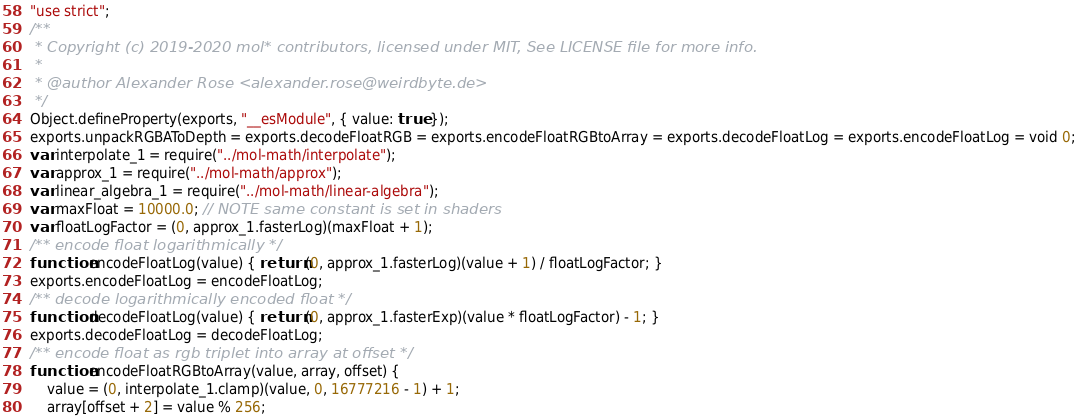<code> <loc_0><loc_0><loc_500><loc_500><_JavaScript_>"use strict";
/**
 * Copyright (c) 2019-2020 mol* contributors, licensed under MIT, See LICENSE file for more info.
 *
 * @author Alexander Rose <alexander.rose@weirdbyte.de>
 */
Object.defineProperty(exports, "__esModule", { value: true });
exports.unpackRGBAToDepth = exports.decodeFloatRGB = exports.encodeFloatRGBtoArray = exports.decodeFloatLog = exports.encodeFloatLog = void 0;
var interpolate_1 = require("../mol-math/interpolate");
var approx_1 = require("../mol-math/approx");
var linear_algebra_1 = require("../mol-math/linear-algebra");
var maxFloat = 10000.0; // NOTE same constant is set in shaders
var floatLogFactor = (0, approx_1.fasterLog)(maxFloat + 1);
/** encode float logarithmically */
function encodeFloatLog(value) { return (0, approx_1.fasterLog)(value + 1) / floatLogFactor; }
exports.encodeFloatLog = encodeFloatLog;
/** decode logarithmically encoded float */
function decodeFloatLog(value) { return (0, approx_1.fasterExp)(value * floatLogFactor) - 1; }
exports.decodeFloatLog = decodeFloatLog;
/** encode float as rgb triplet into array at offset */
function encodeFloatRGBtoArray(value, array, offset) {
    value = (0, interpolate_1.clamp)(value, 0, 16777216 - 1) + 1;
    array[offset + 2] = value % 256;</code> 